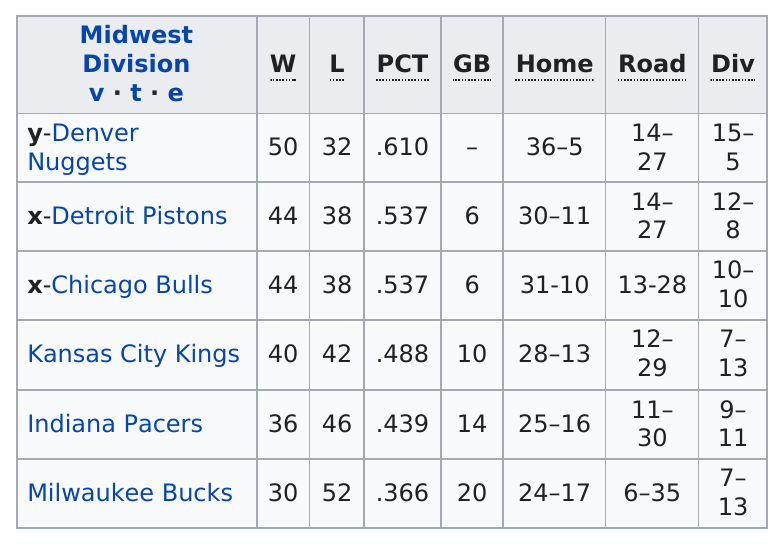Point out several critical features in this image. The team in the Midwest division with the highest number of wins is Denver Nuggets. 